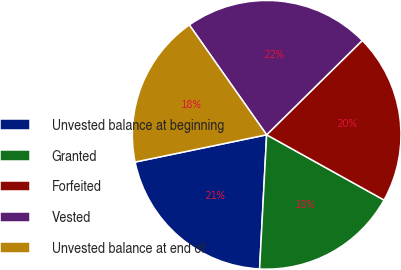Convert chart. <chart><loc_0><loc_0><loc_500><loc_500><pie_chart><fcel>Unvested balance at beginning<fcel>Granted<fcel>Forfeited<fcel>Vested<fcel>Unvested balance at end of<nl><fcel>20.91%<fcel>17.76%<fcel>20.46%<fcel>22.37%<fcel>18.49%<nl></chart> 